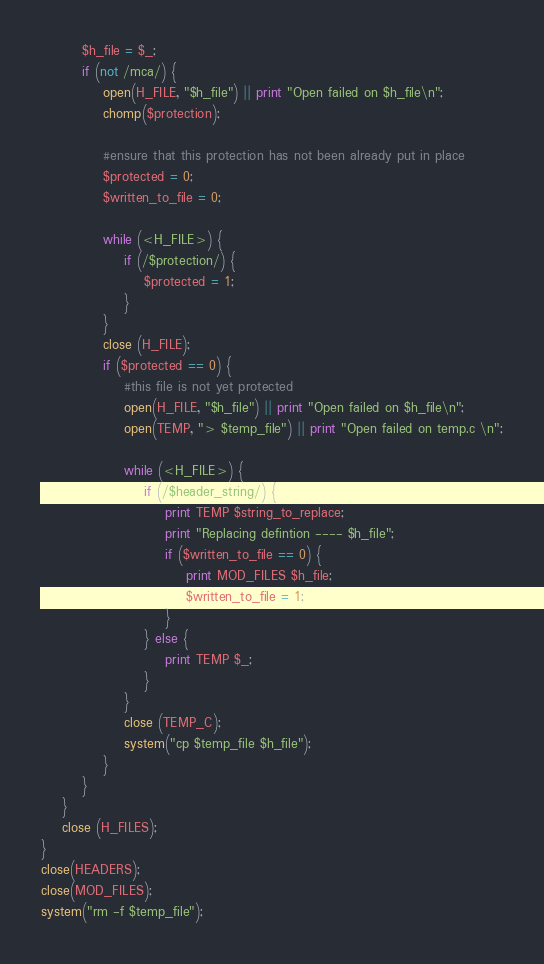Convert code to text. <code><loc_0><loc_0><loc_500><loc_500><_Perl_>        $h_file = $_;
        if (not /mca/) {
            open(H_FILE, "$h_file") || print "Open failed on $h_file\n";
            chomp($protection);

            #ensure that this protection has not been already put in place
            $protected = 0;
            $written_to_file = 0;

            while (<H_FILE>) {
                if (/$protection/) {
                    $protected = 1;
                }
            }
            close (H_FILE);
            if ($protected == 0) { 
                #this file is not yet protected
                open(H_FILE, "$h_file") || print "Open failed on $h_file\n";
                open(TEMP, "> $temp_file") || print "Open failed on temp.c \n";

                while (<H_FILE>) {
                    if (/$header_string/) {
                        print TEMP $string_to_replace;
                        print "Replacing defintion ---- $h_file";
                        if ($written_to_file == 0) {
                            print MOD_FILES $h_file;
                            $written_to_file = 1;
                        }
                    } else {
                        print TEMP $_;
                    }
                }
                close (TEMP_C);
                system("cp $temp_file $h_file");
            }
        }
    }
    close (H_FILES);
}
close(HEADERS);
close(MOD_FILES);
system("rm -f $temp_file");
</code> 